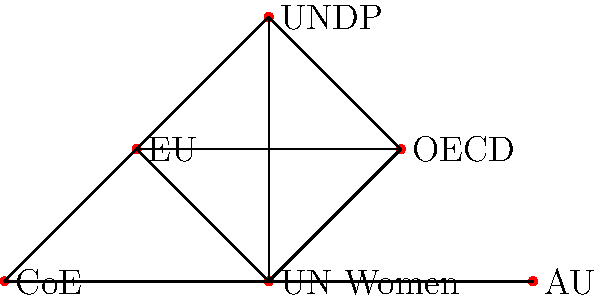In the network diagram of international organizations promoting gender equity in governance, which organization has the highest degree centrality (i.e., the most direct connections to other organizations)? To determine the organization with the highest degree centrality, we need to count the number of direct connections (edges) for each node in the network:

1. UN Women: 5 connections (to OECD, EU, UNDP, CoE, and AU)
2. OECD: 3 connections (to UN Women, EU, and UNDP)
3. EU: 4 connections (to UN Women, OECD, UNDP, and CoE)
4. UNDP: 3 connections (to UN Women, OECD, and EU)
5. CoE: 2 connections (to UN Women and EU)
6. AU: 1 connection (to UN Women)

The organization with the highest number of direct connections is UN Women, with 5 connections.

This high degree centrality suggests that UN Women plays a crucial role in coordinating and collaborating with other international organizations to promote gender equity in governance. Its central position in the network indicates its importance in facilitating information flow and joint initiatives among these organizations.
Answer: UN Women 